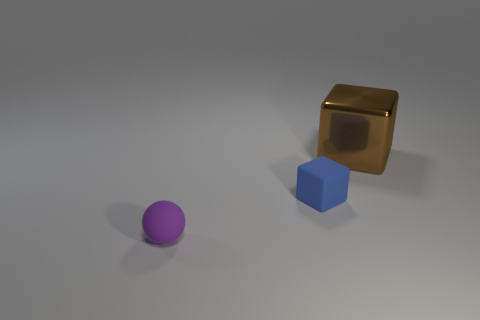Add 1 small purple objects. How many objects exist? 4 Subtract all brown blocks. How many blocks are left? 1 Subtract all cubes. How many objects are left? 1 Subtract 0 cyan spheres. How many objects are left? 3 Subtract all red blocks. Subtract all gray cylinders. How many blocks are left? 2 Subtract all yellow spheres. How many yellow cubes are left? 0 Subtract all blue rubber blocks. Subtract all blue cubes. How many objects are left? 1 Add 1 big brown metallic blocks. How many big brown metallic blocks are left? 2 Add 1 big yellow blocks. How many big yellow blocks exist? 1 